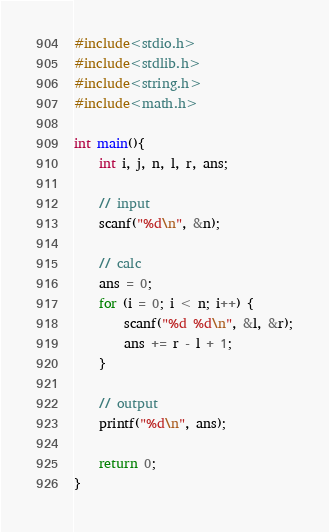Convert code to text. <code><loc_0><loc_0><loc_500><loc_500><_C_>#include<stdio.h>
#include<stdlib.h>
#include<string.h>
#include<math.h>

int main(){
	int i, j, n, l, r, ans;

	// input
	scanf("%d\n", &n);

	// calc
	ans = 0;
	for (i = 0; i < n; i++) {
		scanf("%d %d\n", &l, &r);
		ans += r - l + 1;
	}
	
	// output
	printf("%d\n", ans);

	return 0;
}
</code> 